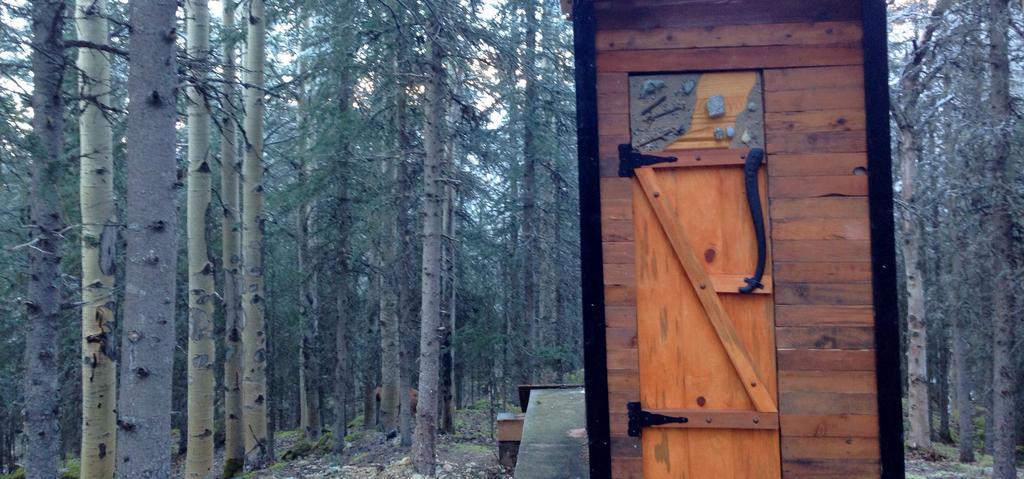Can you describe this image briefly? There is a wooden wall. In the back there are trees. 